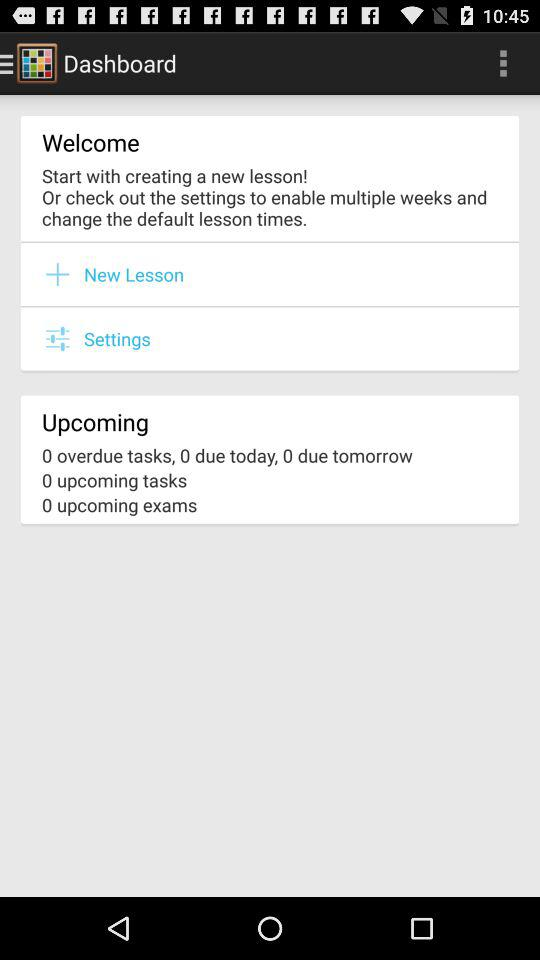What is the app name? The app name is "Timetable". 